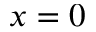Convert formula to latex. <formula><loc_0><loc_0><loc_500><loc_500>x = 0</formula> 